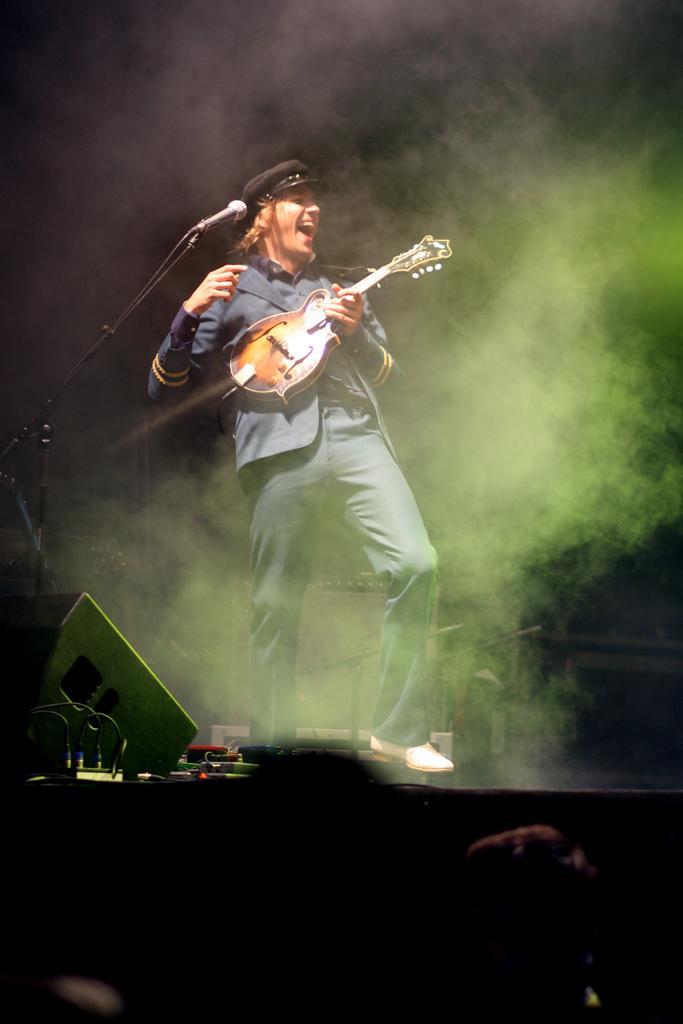In one or two sentences, can you explain what this image depicts? In this image we can see one person standing on the stage, playing guitar and singing. There is one microphone with stand on the stage, some objects on the stage, some smoke, it looks like few people in front of the stage and the image is dark. 